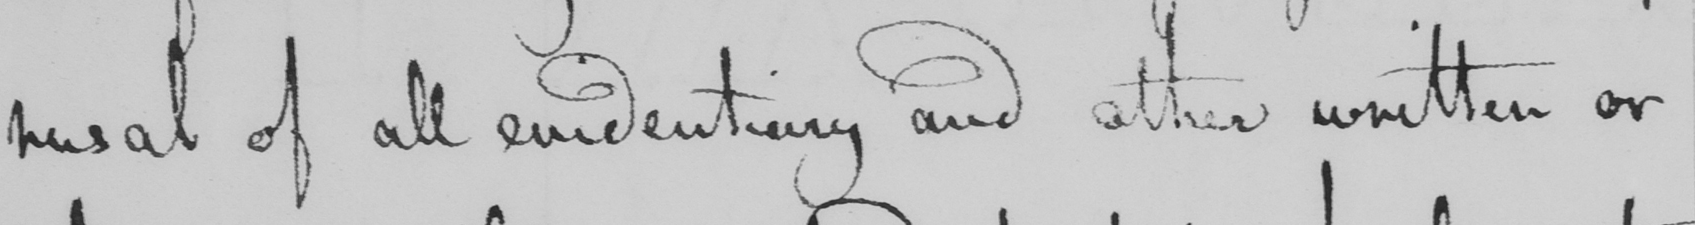Can you tell me what this handwritten text says? rusal of all evidentiary and other written or 